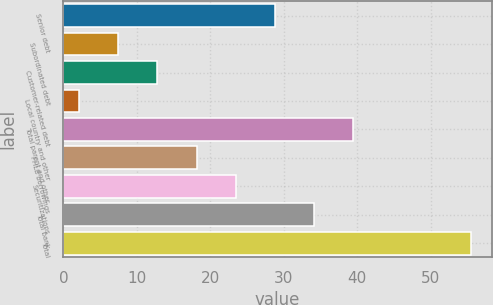Convert chart to OTSL. <chart><loc_0><loc_0><loc_500><loc_500><bar_chart><fcel>Senior debt<fcel>Subordinated debt<fcel>Customer-related debt<fcel>Local country and other<fcel>Total parent and other<fcel>FHLB borrowings<fcel>Securitizations<fcel>Total bank<fcel>Total<nl><fcel>28.8<fcel>7.44<fcel>12.78<fcel>2.1<fcel>39.48<fcel>18.12<fcel>23.46<fcel>34.14<fcel>55.5<nl></chart> 